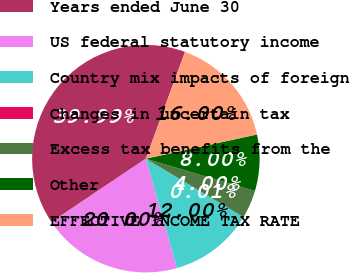<chart> <loc_0><loc_0><loc_500><loc_500><pie_chart><fcel>Years ended June 30<fcel>US federal statutory income<fcel>Country mix impacts of foreign<fcel>Changes in uncertain tax<fcel>Excess tax benefits from the<fcel>Other<fcel>EFFECTIVE INCOME TAX RATE<nl><fcel>39.99%<fcel>20.0%<fcel>12.0%<fcel>0.01%<fcel>4.0%<fcel>8.0%<fcel>16.0%<nl></chart> 